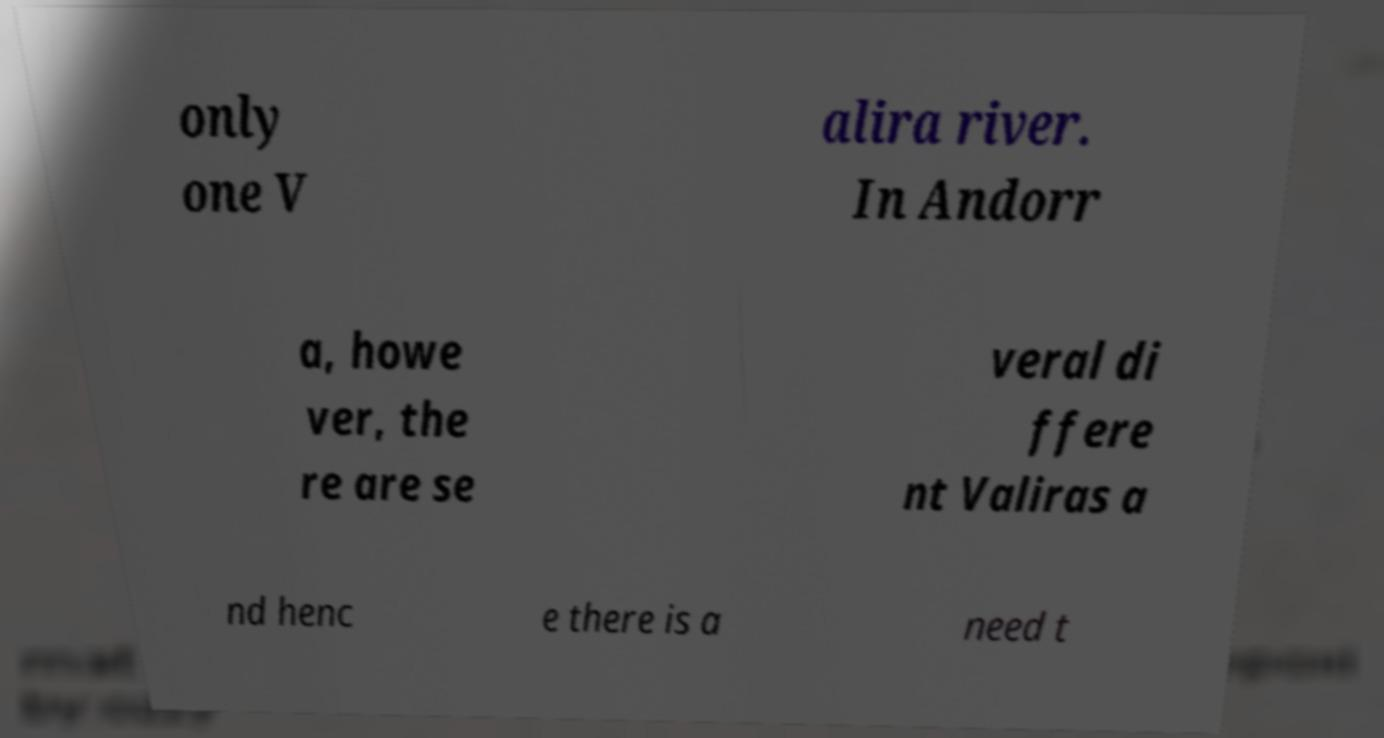Can you read and provide the text displayed in the image?This photo seems to have some interesting text. Can you extract and type it out for me? only one V alira river. In Andorr a, howe ver, the re are se veral di ffere nt Valiras a nd henc e there is a need t 